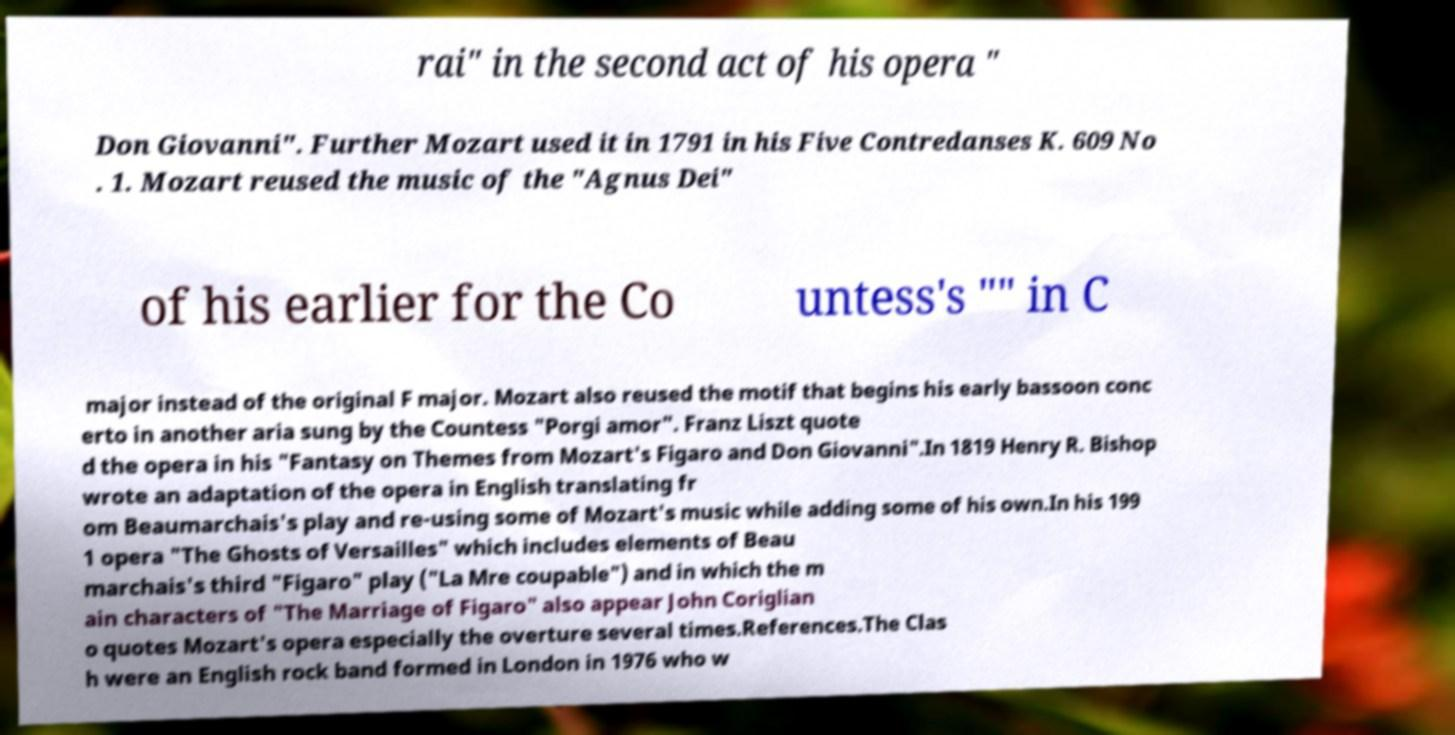What messages or text are displayed in this image? I need them in a readable, typed format. rai" in the second act of his opera " Don Giovanni". Further Mozart used it in 1791 in his Five Contredanses K. 609 No . 1. Mozart reused the music of the "Agnus Dei" of his earlier for the Co untess's "" in C major instead of the original F major. Mozart also reused the motif that begins his early bassoon conc erto in another aria sung by the Countess "Porgi amor". Franz Liszt quote d the opera in his "Fantasy on Themes from Mozart's Figaro and Don Giovanni".In 1819 Henry R. Bishop wrote an adaptation of the opera in English translating fr om Beaumarchais's play and re-using some of Mozart's music while adding some of his own.In his 199 1 opera "The Ghosts of Versailles" which includes elements of Beau marchais's third "Figaro" play ("La Mre coupable") and in which the m ain characters of "The Marriage of Figaro" also appear John Coriglian o quotes Mozart's opera especially the overture several times.References.The Clas h were an English rock band formed in London in 1976 who w 